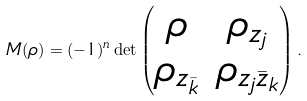Convert formula to latex. <formula><loc_0><loc_0><loc_500><loc_500>M ( \rho ) = ( - 1 ) ^ { n } \det \begin{pmatrix} \rho & \rho _ { z _ { j } } \\ \rho _ { z _ { \bar { k } } } & \rho _ { z _ { j } \bar { z } _ { k } } \end{pmatrix} .</formula> 